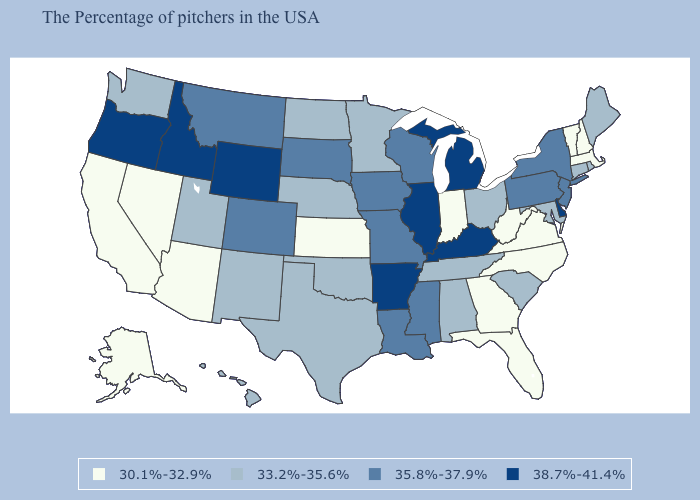What is the lowest value in states that border South Dakota?
Be succinct. 33.2%-35.6%. Does New Hampshire have a lower value than West Virginia?
Quick response, please. No. What is the value of New Mexico?
Keep it brief. 33.2%-35.6%. Does Oregon have a lower value than Wyoming?
Concise answer only. No. Name the states that have a value in the range 30.1%-32.9%?
Quick response, please. Massachusetts, New Hampshire, Vermont, Virginia, North Carolina, West Virginia, Florida, Georgia, Indiana, Kansas, Arizona, Nevada, California, Alaska. Among the states that border North Dakota , which have the highest value?
Keep it brief. South Dakota, Montana. Name the states that have a value in the range 30.1%-32.9%?
Short answer required. Massachusetts, New Hampshire, Vermont, Virginia, North Carolina, West Virginia, Florida, Georgia, Indiana, Kansas, Arizona, Nevada, California, Alaska. What is the lowest value in the USA?
Give a very brief answer. 30.1%-32.9%. Does Illinois have the highest value in the MidWest?
Write a very short answer. Yes. Is the legend a continuous bar?
Concise answer only. No. Name the states that have a value in the range 35.8%-37.9%?
Be succinct. New York, New Jersey, Pennsylvania, Wisconsin, Mississippi, Louisiana, Missouri, Iowa, South Dakota, Colorado, Montana. What is the lowest value in the South?
Give a very brief answer. 30.1%-32.9%. Which states have the lowest value in the USA?
Concise answer only. Massachusetts, New Hampshire, Vermont, Virginia, North Carolina, West Virginia, Florida, Georgia, Indiana, Kansas, Arizona, Nevada, California, Alaska. Among the states that border Oregon , does Nevada have the highest value?
Keep it brief. No. What is the highest value in states that border Missouri?
Be succinct. 38.7%-41.4%. 